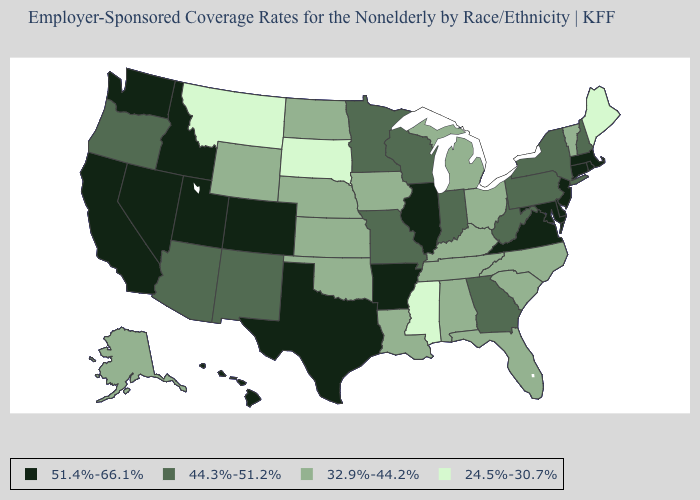Name the states that have a value in the range 51.4%-66.1%?
Write a very short answer. Arkansas, California, Colorado, Connecticut, Delaware, Hawaii, Idaho, Illinois, Maryland, Massachusetts, Nevada, New Jersey, Rhode Island, Texas, Utah, Virginia, Washington. What is the value of New Hampshire?
Give a very brief answer. 44.3%-51.2%. Does Massachusetts have the same value as Colorado?
Write a very short answer. Yes. What is the highest value in the Northeast ?
Keep it brief. 51.4%-66.1%. Is the legend a continuous bar?
Answer briefly. No. Does Utah have a lower value than North Dakota?
Write a very short answer. No. Among the states that border Virginia , does Maryland have the highest value?
Keep it brief. Yes. Name the states that have a value in the range 44.3%-51.2%?
Give a very brief answer. Arizona, Georgia, Indiana, Minnesota, Missouri, New Hampshire, New Mexico, New York, Oregon, Pennsylvania, West Virginia, Wisconsin. What is the value of New York?
Be succinct. 44.3%-51.2%. Does Connecticut have the highest value in the USA?
Short answer required. Yes. Does Kansas have the same value as Wisconsin?
Be succinct. No. Name the states that have a value in the range 44.3%-51.2%?
Answer briefly. Arizona, Georgia, Indiana, Minnesota, Missouri, New Hampshire, New Mexico, New York, Oregon, Pennsylvania, West Virginia, Wisconsin. Does New York have the highest value in the Northeast?
Quick response, please. No. Is the legend a continuous bar?
Concise answer only. No. 